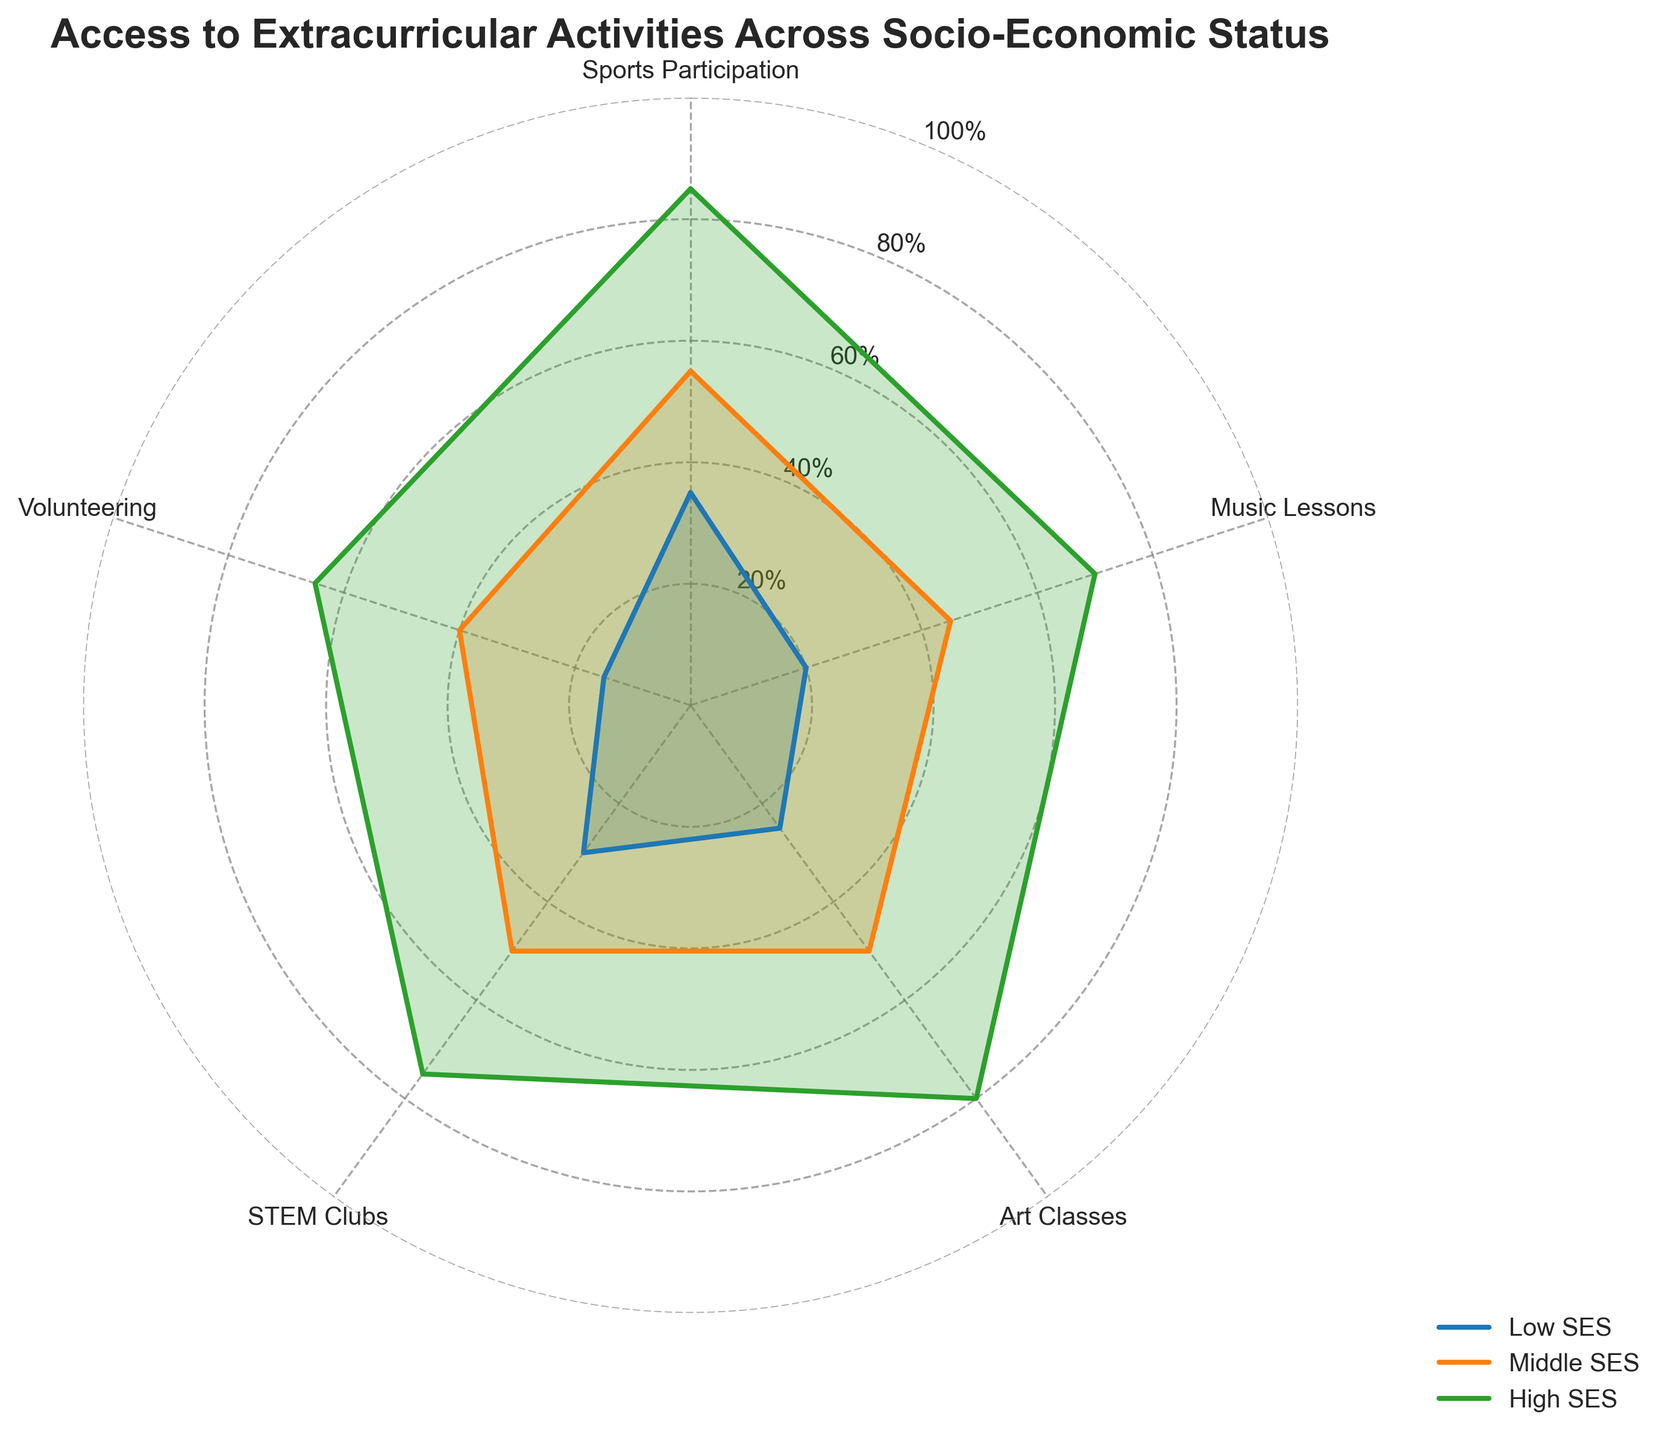What's the title of the figure? The title is written at the top of the figure. It is meant to summarize the subject of the chart.
Answer: Access to Extracurricular Activities Across Socio-Economic Status Which socio-economic status (SES) group participates least in Volunteering? To find this, look for the Volunteering category on the radar chart and find the lowest value among the three SES groups.
Answer: Low SES What is the difference in Sports Participation between Low SES and High SES? Check the values for Sports Participation for both Low SES (35) and High SES (85), then calculate the difference: 85 - 35 = 50.
Answer: 50 Which category has the highest participation rate for Middle SES? Find the category with the highest value among the different options for the Middle SES group. The highest value here is 55, which corresponds to Sports Participation.
Answer: Sports Participation How much higher is the participation in Music Lessons for High SES compared to Low SES? Look for Music Lessons values for both High SES (70) and Low SES (20) groups. Subtract the lower value from the higher value: 70 - 20 = 50.
Answer: 50 What is the average participation in Art Classes across all SES groups? To calculate the average, add the values for Art Classes for each SES group and then divide by the number of groups: (25 + 50 + 80) / 3 = 51.67.
Answer: 51.67 Which activity has the smallest participation gap between Middle SES and High SES groups? Calculate the difference in participation rates for each activity between Middle SES and High SES, then find the smallest gap: Sports Participation (85-55=30), Music Lessons (70-45=25), Art Classes (80-50=30), STEM Clubs (75-50=25), Volunteering (65-40=25). The three smallest gaps are in Music Lessons, STEM Clubs, and Volunteering, each with a gap of 25.
Answer: Music Lessons, STEM Clubs, Volunteering By how much does the participation in STEM Clubs of High SES exceed that of Low SES? Identify the STEM Clubs values for both High SES (75) and Low SES (30) groups. Subtract the Low SES value from the High SES value: 75 - 30 = 45.
Answer: 45 In how many categories does Middle SES have higher participation than Low SES but lower than High SES? Compare the values for each category across the three SES groups. Sports Participation (Low<Middle<High), Music Lessons (Low<Middle<High), Art Classes (Low<Middle<High), STEM Clubs (Low=Middle<High), Volunteering (Low<Middle<High). The categories where Middle SES has higher participation than Low SES but lower than High SES are Sports Participation, Music Lessons, Art Classes, and Volunteering.
Answer: 4 